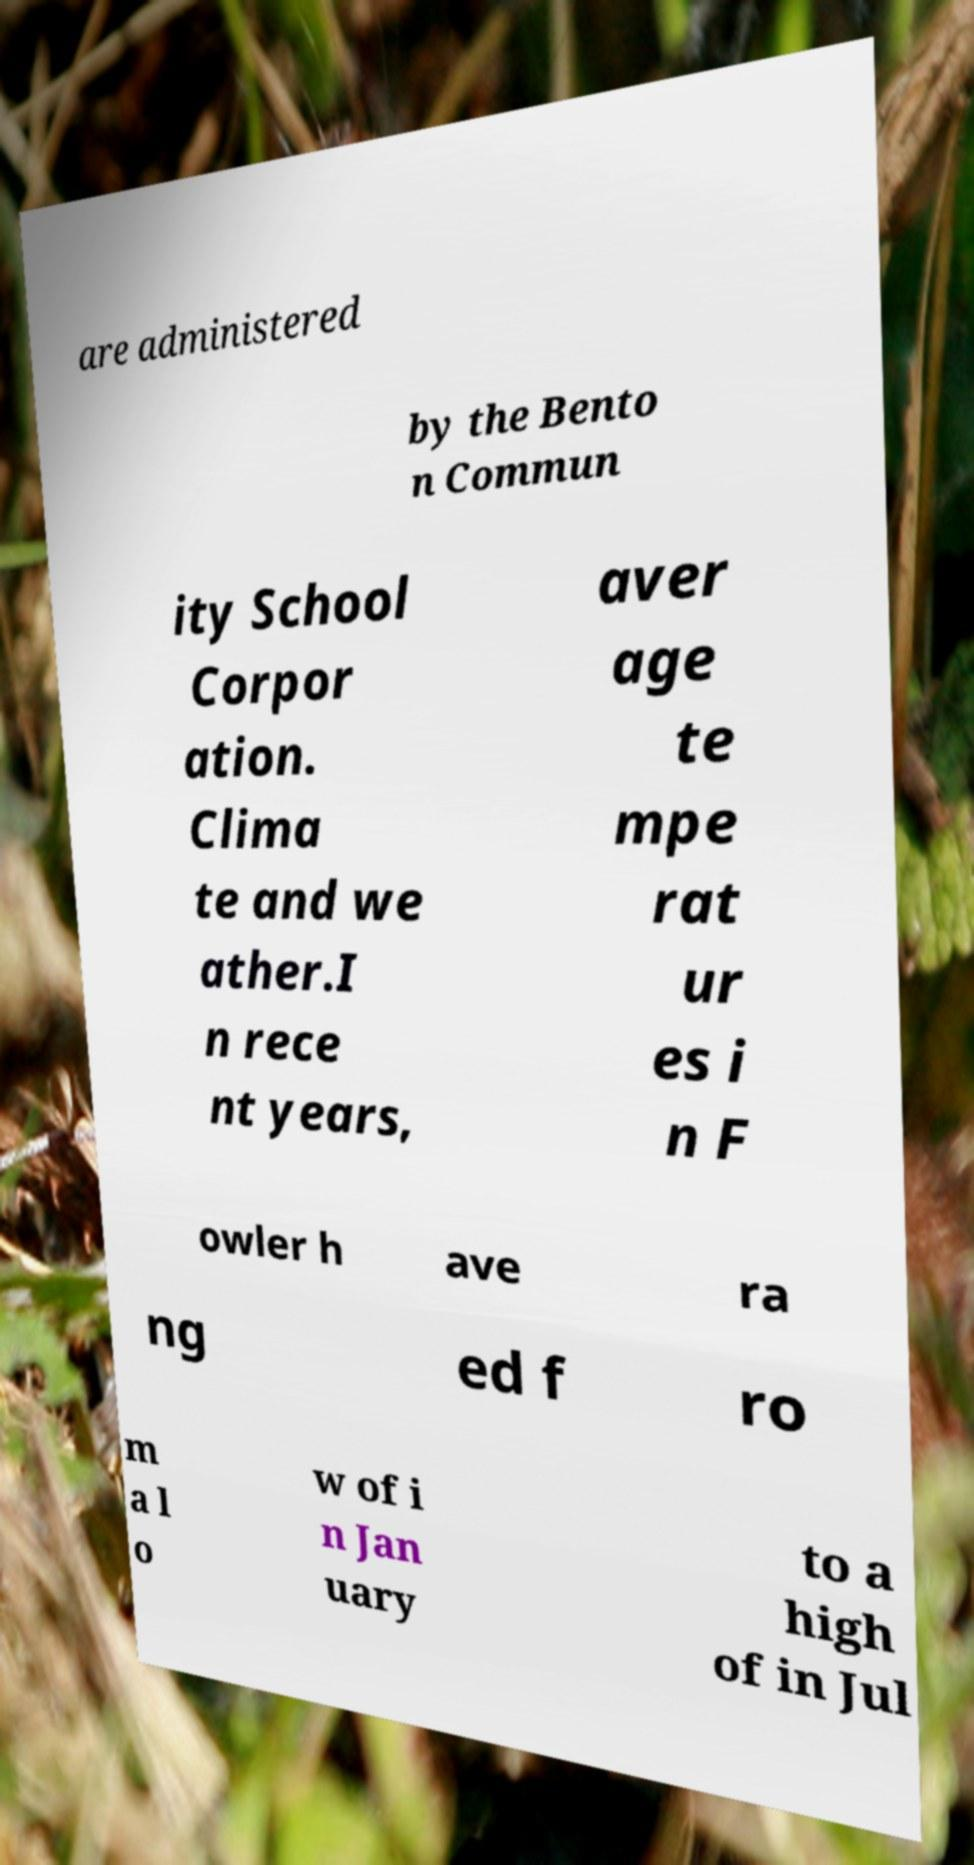Could you extract and type out the text from this image? are administered by the Bento n Commun ity School Corpor ation. Clima te and we ather.I n rece nt years, aver age te mpe rat ur es i n F owler h ave ra ng ed f ro m a l o w of i n Jan uary to a high of in Jul 